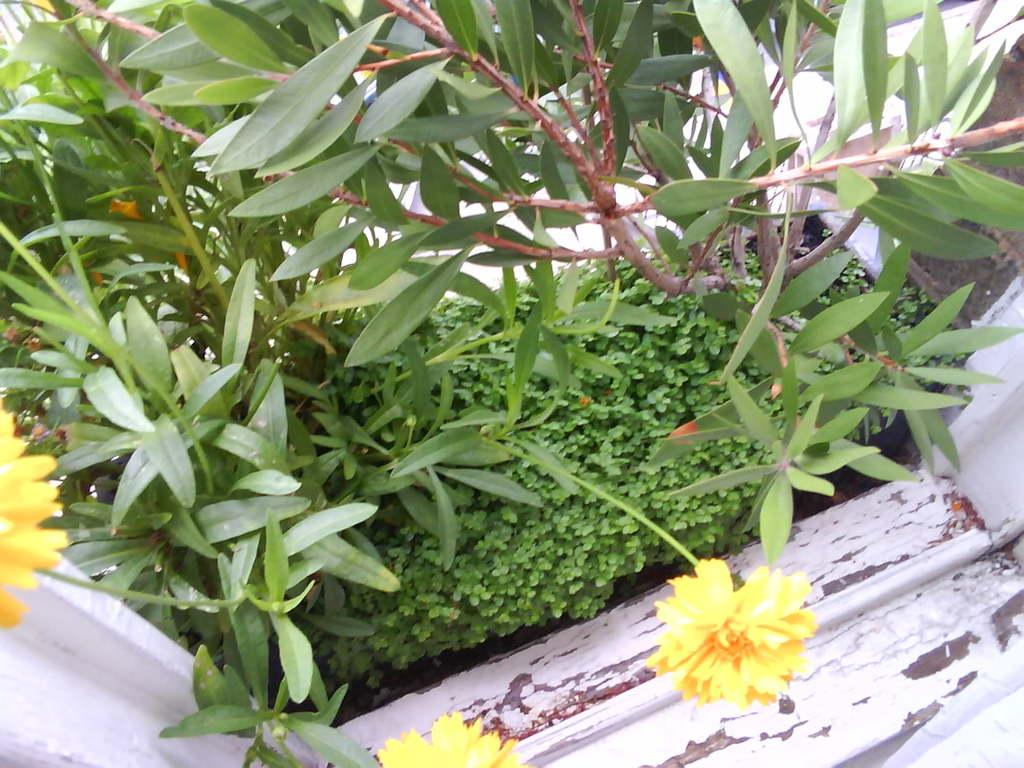What type of living organisms can be seen in the image? Plants can be seen in the image. What specific feature of the plants can be observed in the image? There are yellow color flowers in the image. What type of trains can be seen in the image? There are no trains present in the image. What type of pen is being used to draw the plants in the image? There is no pen visible in the image, and the plants are real, not drawn. 